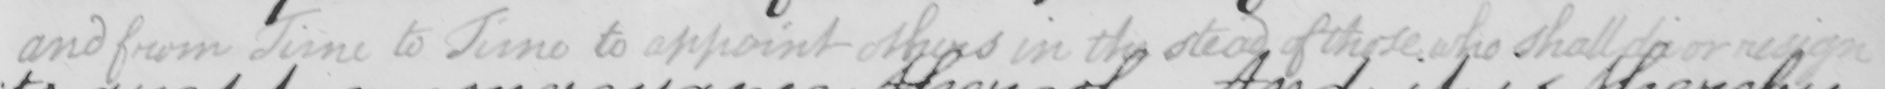Can you read and transcribe this handwriting? and from June to June to appoint others in the stead of those who shall die or resign 